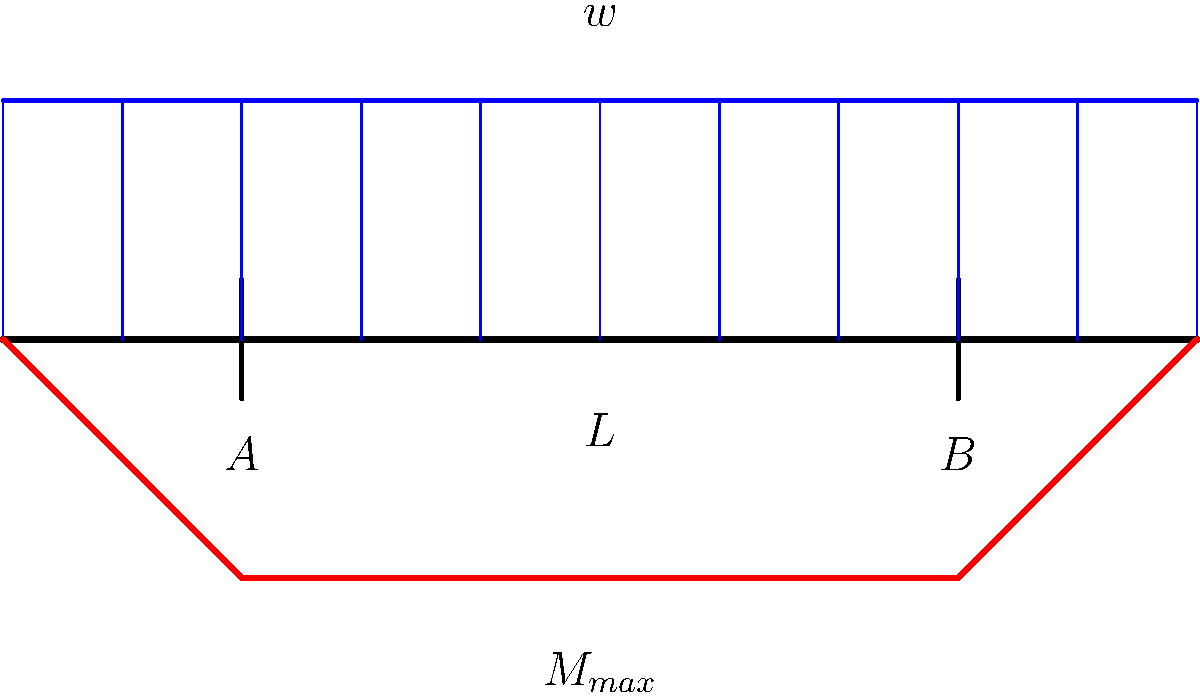A simply supported beam of length $L$ is subjected to a uniformly distributed load $w$ along its entire length. Using the bending moment diagram shown, determine the maximum bending moment $M_{max}$ in terms of $w$ and $L$. To determine the maximum bending moment, we'll follow these steps:

1) For a simply supported beam with a uniformly distributed load, the bending moment diagram is parabolic with the maximum occurring at the center of the beam.

2) The reaction forces at the supports A and B are equal due to symmetry:
   $R_A = R_B = \frac{wL}{2}$

3) The maximum bending moment occurs at the center of the beam (L/2). We can calculate it using the method of sections or by using the formula for maximum moment in a simply supported beam with UDL:

   $M_{max} = \frac{wL^2}{8}$

4) This can be derived as follows:
   - Consider half of the beam
   - Moment at center = Reaction force × (L/2) - Distributed load effect
   - $M_{max} = \frac{wL}{2} \cdot \frac{L}{2} - w \cdot \frac{L}{2} \cdot \frac{L}{4}$
   - $M_{max} = \frac{wL^2}{4} - \frac{wL^2}{8} = \frac{wL^2}{8}$

5) The bending moment diagram confirms this result, showing a parabolic shape with the maximum at the center.
Answer: $M_{max} = \frac{wL^2}{8}$ 